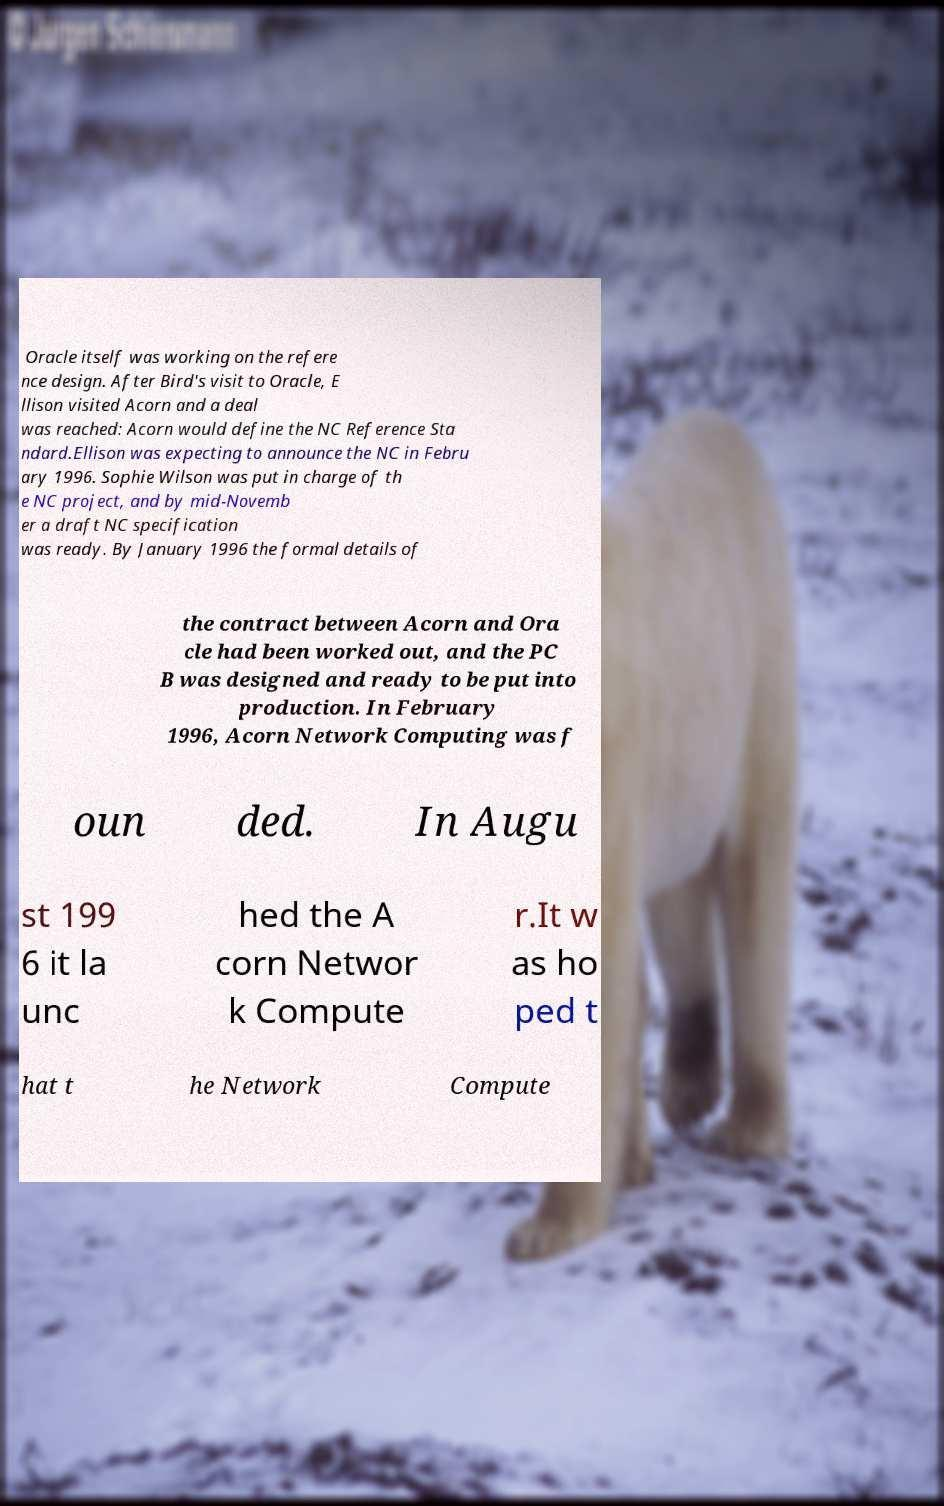Could you assist in decoding the text presented in this image and type it out clearly? Oracle itself was working on the refere nce design. After Bird's visit to Oracle, E llison visited Acorn and a deal was reached: Acorn would define the NC Reference Sta ndard.Ellison was expecting to announce the NC in Febru ary 1996. Sophie Wilson was put in charge of th e NC project, and by mid-Novemb er a draft NC specification was ready. By January 1996 the formal details of the contract between Acorn and Ora cle had been worked out, and the PC B was designed and ready to be put into production. In February 1996, Acorn Network Computing was f oun ded. In Augu st 199 6 it la unc hed the A corn Networ k Compute r.It w as ho ped t hat t he Network Compute 